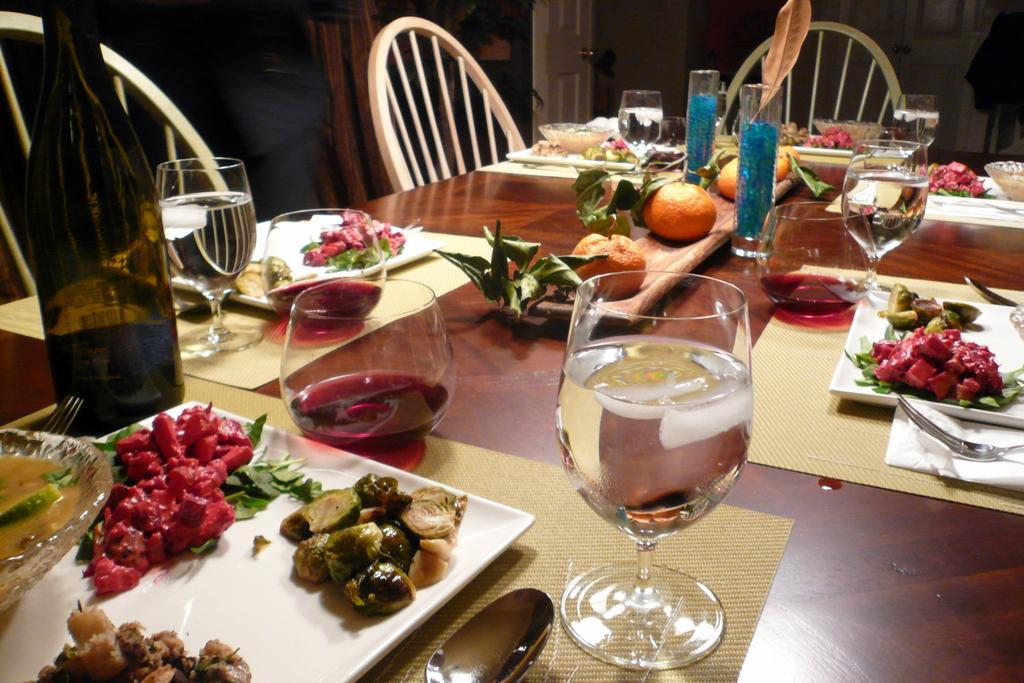Describe this image in one or two sentences. In this picture we have a table with place and some food arranged on them, also they are wine bottle, wine glasses, water bottle and some fruits. 